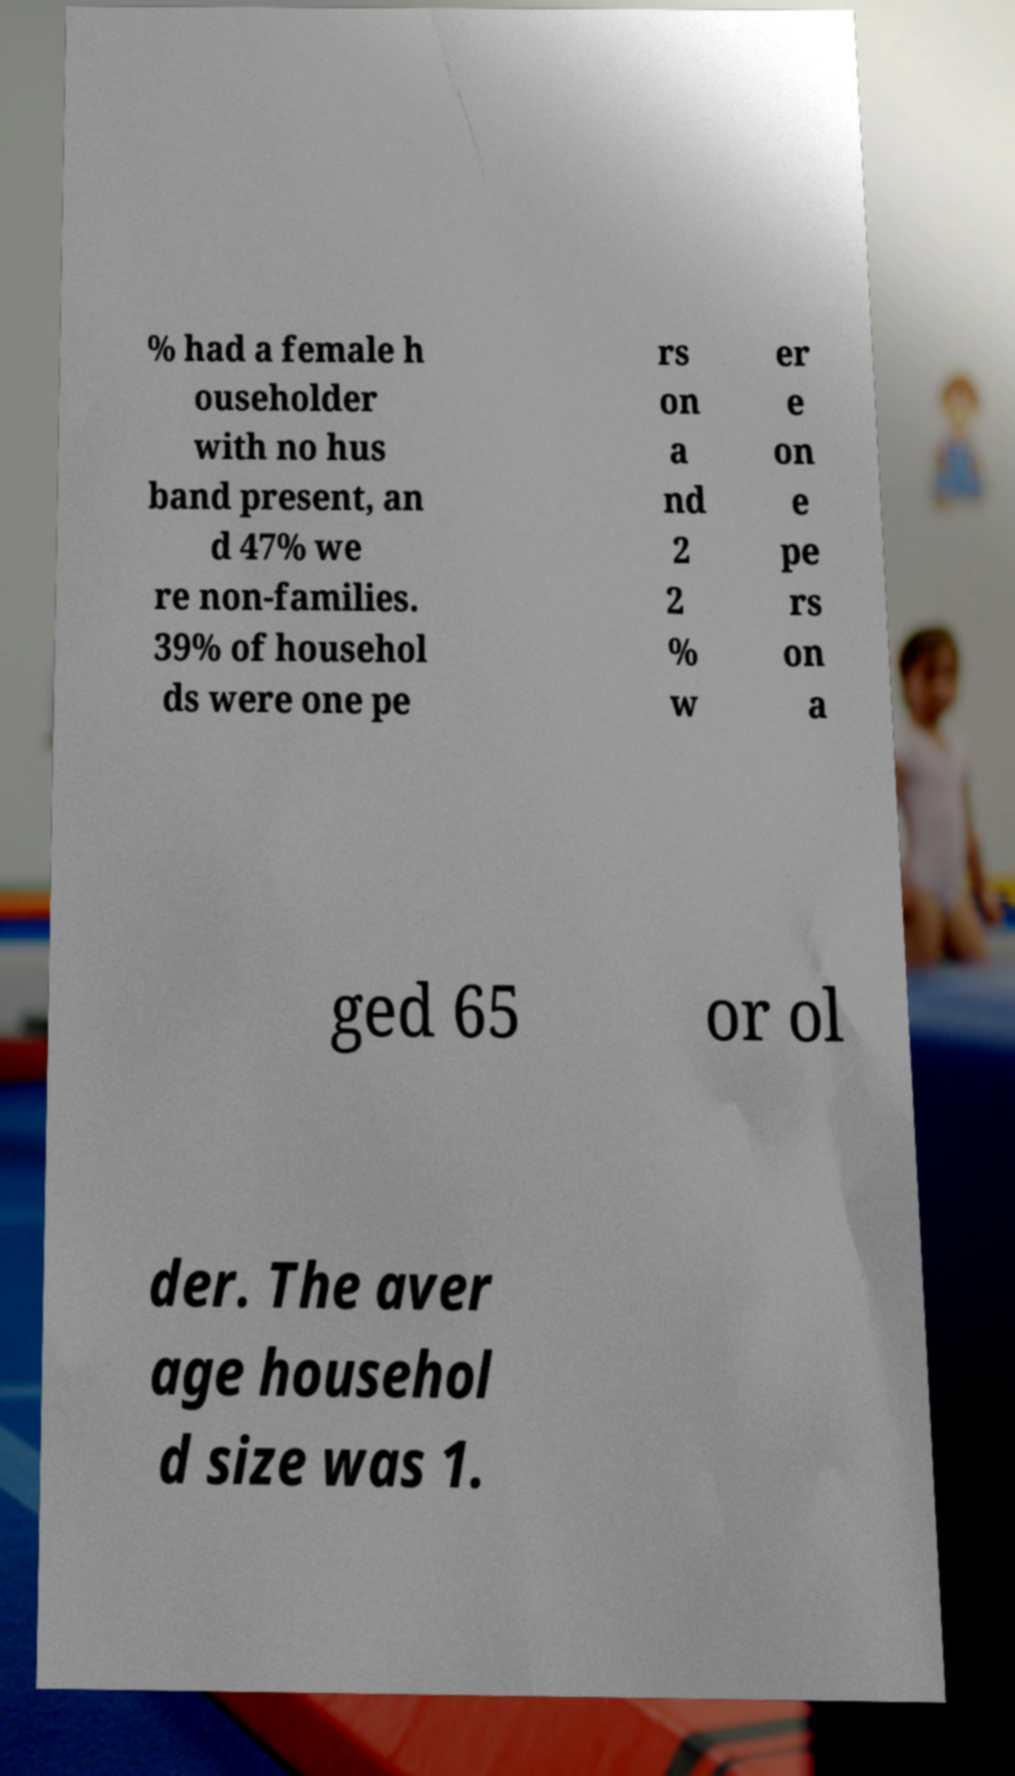For documentation purposes, I need the text within this image transcribed. Could you provide that? % had a female h ouseholder with no hus band present, an d 47% we re non-families. 39% of househol ds were one pe rs on a nd 2 2 % w er e on e pe rs on a ged 65 or ol der. The aver age househol d size was 1. 